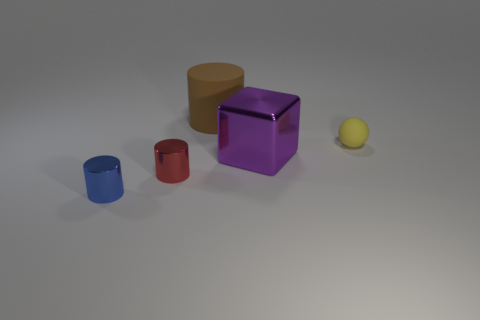The cylinder that is right of the blue cylinder and in front of the cube is what color?
Provide a succinct answer. Red. There is a purple metallic thing on the left side of the yellow ball; what number of big purple metallic objects are in front of it?
Offer a very short reply. 0. Do the red thing and the large brown object have the same shape?
Offer a very short reply. Yes. Is the shape of the large brown matte thing the same as the blue object that is in front of the big brown thing?
Keep it short and to the point. Yes. There is a rubber thing to the left of the tiny object that is behind the tiny cylinder on the right side of the blue object; what color is it?
Ensure brevity in your answer.  Brown. Is the shape of the big thing behind the yellow matte ball the same as  the tiny red thing?
Your answer should be very brief. Yes. What material is the sphere?
Give a very brief answer. Rubber. There is a tiny thing that is to the right of the big object left of the big object that is on the right side of the large brown cylinder; what is its shape?
Your answer should be compact. Sphere. How many other objects are the same shape as the small red metallic object?
Your response must be concise. 2. There is a small rubber thing; is it the same color as the big thing in front of the brown rubber cylinder?
Your answer should be compact. No. 